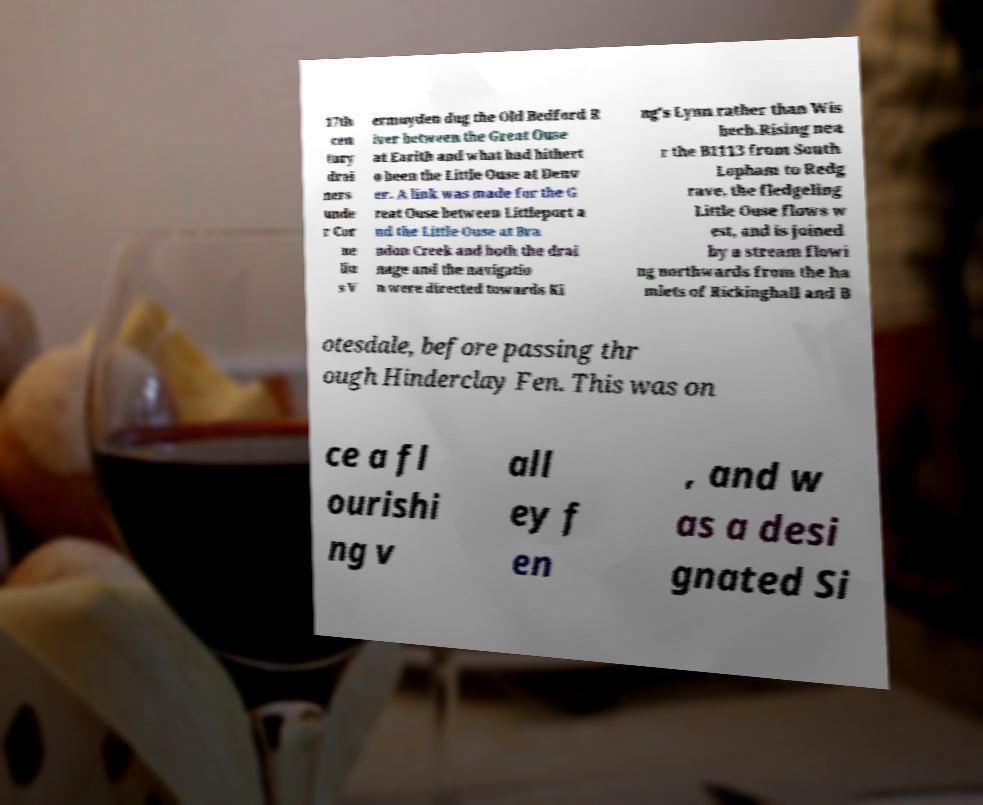Please read and relay the text visible in this image. What does it say? 17th cen tury drai ners unde r Cor ne liu s V ermuyden dug the Old Bedford R iver between the Great Ouse at Earith and what had hithert o been the Little Ouse at Denv er. A link was made for the G reat Ouse between Littleport a nd the Little Ouse at Bra ndon Creek and both the drai nage and the navigatio n were directed towards Ki ng's Lynn rather than Wis bech.Rising nea r the B1113 from South Lopham to Redg rave, the fledgeling Little Ouse flows w est, and is joined by a stream flowi ng northwards from the ha mlets of Rickinghall and B otesdale, before passing thr ough Hinderclay Fen. This was on ce a fl ourishi ng v all ey f en , and w as a desi gnated Si 